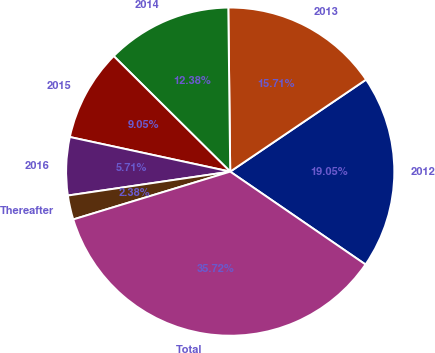Convert chart to OTSL. <chart><loc_0><loc_0><loc_500><loc_500><pie_chart><fcel>2012<fcel>2013<fcel>2014<fcel>2015<fcel>2016<fcel>Thereafter<fcel>Total<nl><fcel>19.05%<fcel>15.71%<fcel>12.38%<fcel>9.05%<fcel>5.71%<fcel>2.38%<fcel>35.72%<nl></chart> 